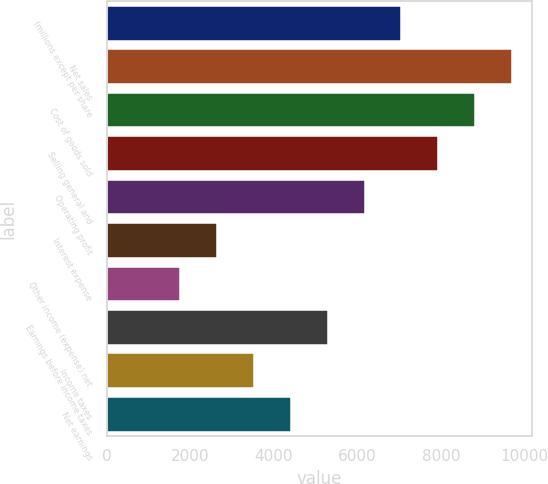Convert chart. <chart><loc_0><loc_0><loc_500><loc_500><bar_chart><fcel>(millions except per share<fcel>Net sales<fcel>Cost of goods sold<fcel>Selling general and<fcel>Operating profit<fcel>Interest expense<fcel>Other income (expense) net<fcel>Earnings before income taxes<fcel>Income taxes<fcel>Net earnings<nl><fcel>7049.6<fcel>9692.48<fcel>8811.52<fcel>7930.56<fcel>6168.64<fcel>2644.8<fcel>1763.84<fcel>5287.68<fcel>3525.76<fcel>4406.72<nl></chart> 